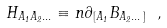Convert formula to latex. <formula><loc_0><loc_0><loc_500><loc_500>H _ { A _ { 1 } A _ { 2 } \dots } \equiv n \partial _ { [ A _ { 1 } } B _ { A _ { 2 } \dots ] } \ ,</formula> 